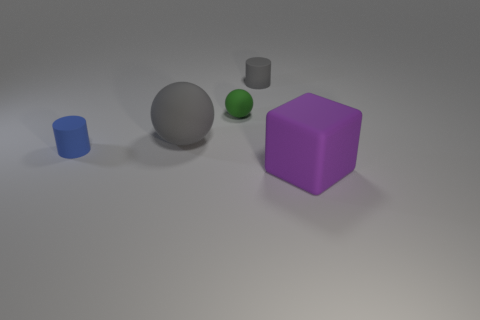The cube that is the same material as the blue cylinder is what color?
Your answer should be very brief. Purple. Do the small cylinder that is left of the gray rubber cylinder and the rubber sphere behind the large gray matte ball have the same color?
Your answer should be very brief. No. How many cubes are either green matte things or gray objects?
Give a very brief answer. 0. Are there an equal number of tiny blue matte things that are right of the big gray sphere and small green rubber things?
Your answer should be compact. No. What material is the tiny cylinder that is behind the cylinder in front of the small rubber thing that is to the right of the small green sphere?
Your response must be concise. Rubber. There is a object that is the same color as the big rubber sphere; what is it made of?
Keep it short and to the point. Rubber. How many objects are matte objects that are in front of the small gray matte cylinder or small purple metallic cylinders?
Your response must be concise. 4. How many objects are either small red rubber blocks or balls in front of the green matte thing?
Offer a very short reply. 1. There is a small cylinder that is left of the big object that is on the left side of the cube; how many small green rubber spheres are on the right side of it?
Your answer should be very brief. 1. There is a ball that is the same size as the rubber cube; what material is it?
Your answer should be very brief. Rubber. 